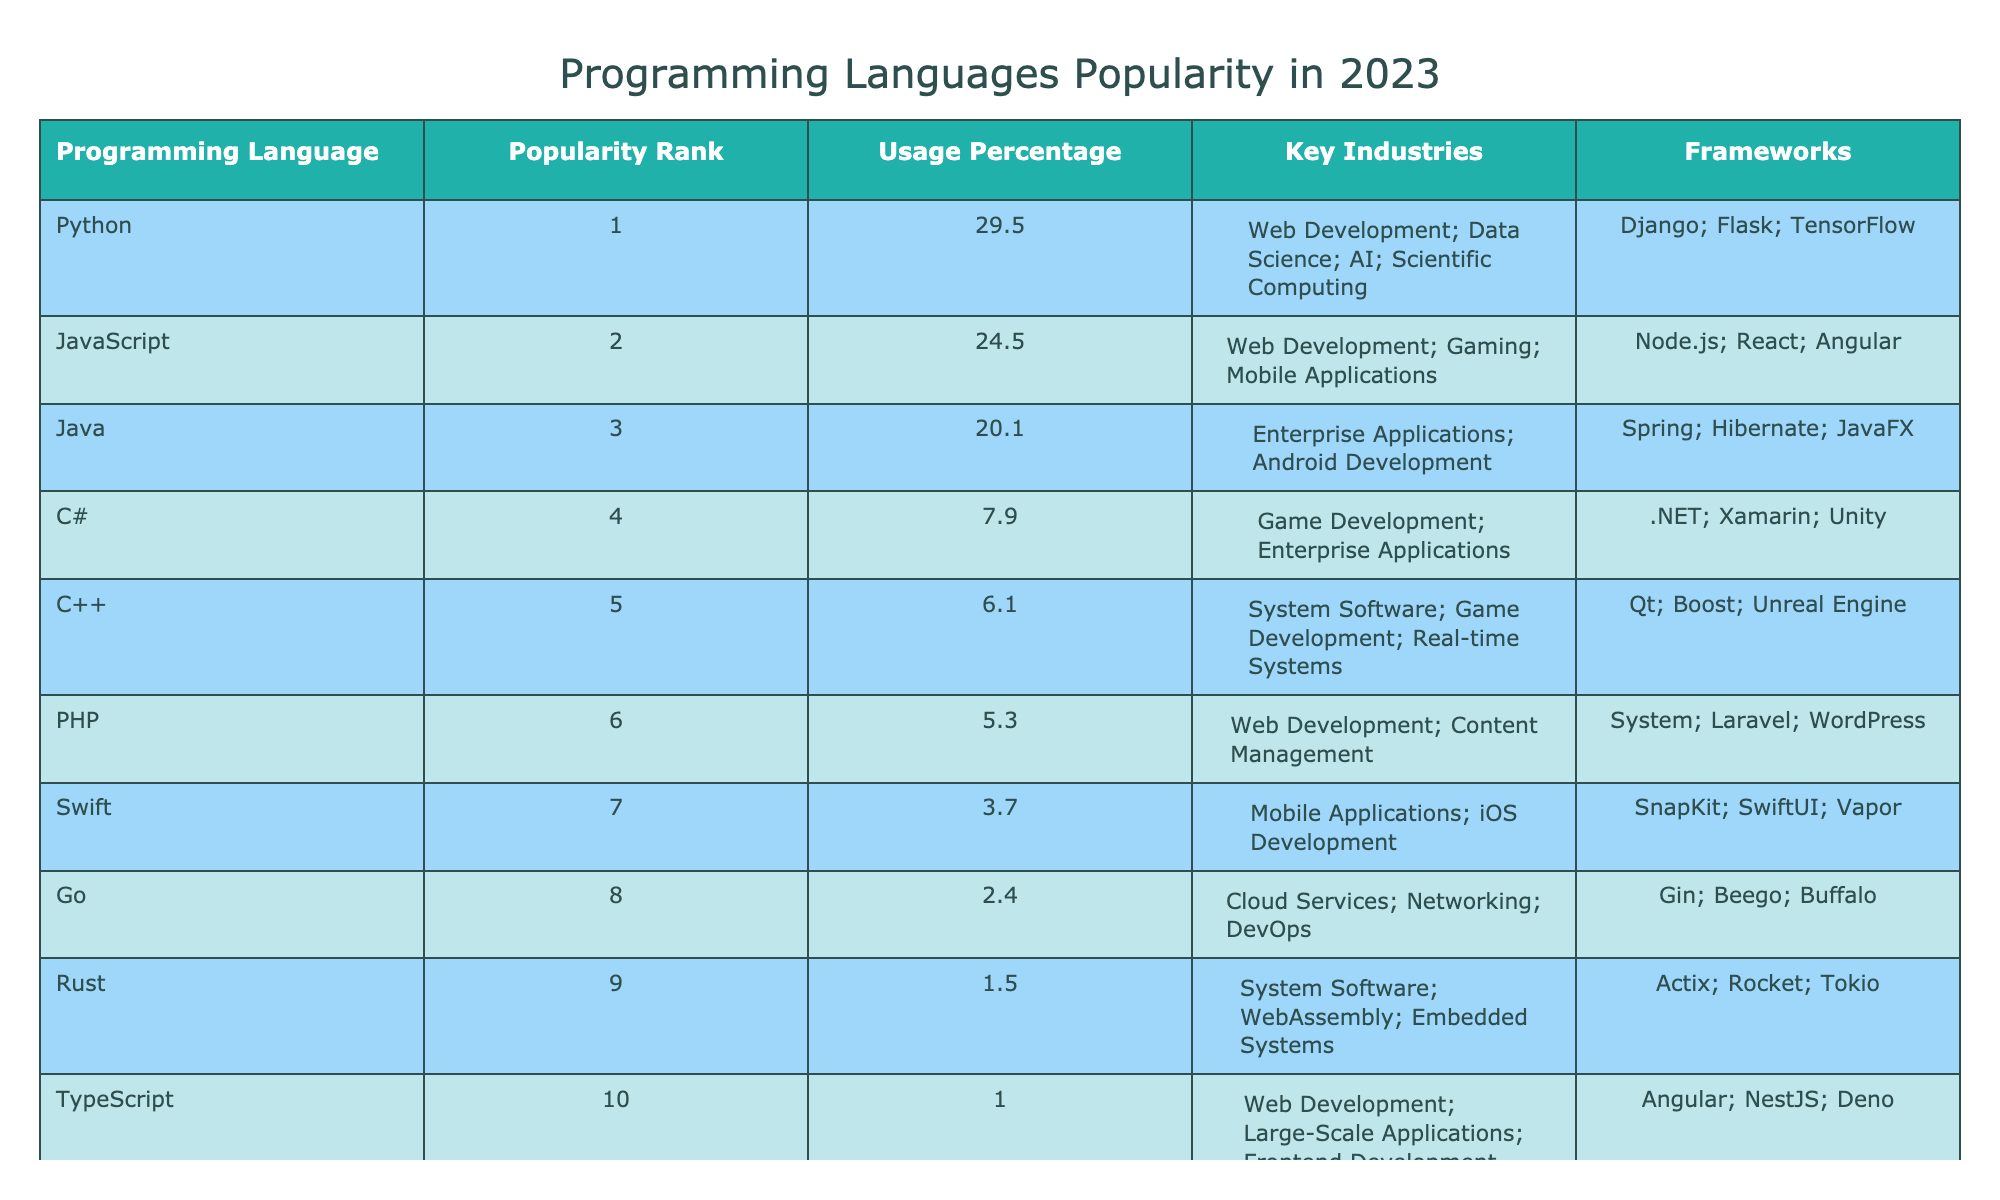What is the programming language with the highest popularity rank? According to the table, the programming language with the highest popularity rank is Python, which is ranked 1.
Answer: Python What percentage of usage does JavaScript have? From the table, the usage percentage for JavaScript is listed as 24.5%.
Answer: 24.5% Which programming language is used primarily in game development? The table lists C# and C++ under the key industries associated with game development. However, C# is specifically mentioned as "Game Development" alongside its other industry, so it can be considered a primary language for this purpose.
Answer: C# What is the difference in usage percentage between Java and C#? The usage percentage for Java is 20.1% and for C# is 7.9%. To find the difference, subtract C#'s percentage from Java's: 20.1% - 7.9% = 12.2%.
Answer: 12.2% Is Rust more popular than Go? Based on the popularity ranks in the table, Rust is ranked 9th and Go is ranked 8th. Since Rust has a lower rank number, it is considered less popular than Go.
Answer: No Which programming language has the least popularity? By examining the popularity ranks, Rust ranks 9th overall, thus it is the least popular programming language listed in the table.
Answer: Rust How many programming languages have a usage percentage of over 10%? The languages with a usage percentage over 10% are Python (29.5%), JavaScript (24.5%), and Java (20.1%). This totals to three languages.
Answer: 3 What is the average usage percentage of the top three programming languages? The usage percentages for the top three languages are: Python (29.5%), JavaScript (24.5%), and Java (20.1%). To find the average, sum these values: 29.5 + 24.5 + 20.1 = 74.1. Then, divide by the number of languages, which is 3: 74.1 / 3 = 24.7.
Answer: 24.7 Which industry is associated with the highest ranked language? Python, the highest ranked language, is associated with multiple industries, including Web Development, Data Science, AI, and Scientific Computing.
Answer: Web Development, Data Science, AI, Scientific Computing 